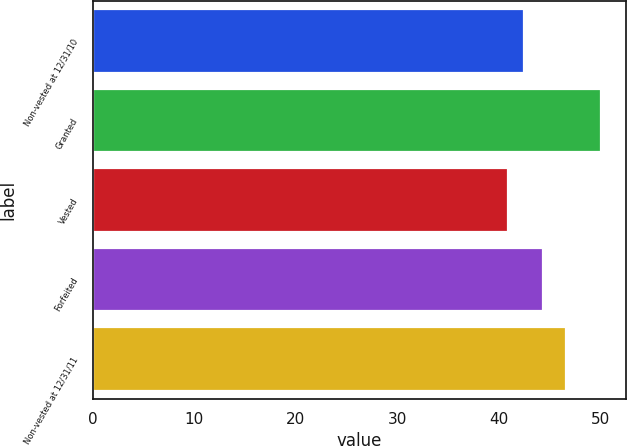<chart> <loc_0><loc_0><loc_500><loc_500><bar_chart><fcel>Non-vested at 12/31/10<fcel>Granted<fcel>Vested<fcel>Forfeited<fcel>Non-vested at 12/31/11<nl><fcel>42.52<fcel>50.07<fcel>40.89<fcel>44.41<fcel>46.6<nl></chart> 